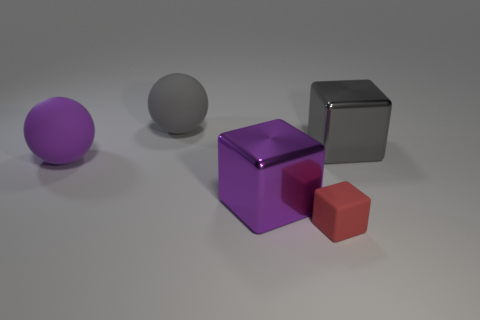There is a purple object that is the same material as the large gray block; what shape is it?
Your answer should be compact. Cube. Does the purple object on the right side of the gray rubber thing have the same size as the big gray block?
Make the answer very short. Yes. How many objects are large metallic things right of the rubber cube or matte objects that are to the right of the large purple matte ball?
Your response must be concise. 3. Does the cube that is to the left of the red cube have the same color as the small rubber cube?
Give a very brief answer. No. How many metal things are either cubes or cyan cubes?
Offer a very short reply. 2. The tiny rubber object is what shape?
Ensure brevity in your answer.  Cube. Is there anything else that has the same material as the large gray ball?
Your answer should be compact. Yes. Are the big purple ball and the gray block made of the same material?
Give a very brief answer. No. Is there a metal object in front of the metallic object right of the purple thing to the right of the purple rubber thing?
Offer a very short reply. Yes. How many other things are there of the same shape as the purple rubber object?
Provide a succinct answer. 1. 